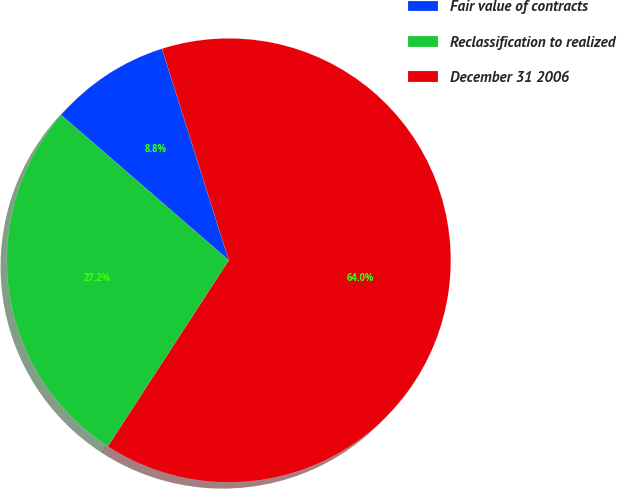Convert chart to OTSL. <chart><loc_0><loc_0><loc_500><loc_500><pie_chart><fcel>Fair value of contracts<fcel>Reclassification to realized<fcel>December 31 2006<nl><fcel>8.77%<fcel>27.19%<fcel>64.04%<nl></chart> 